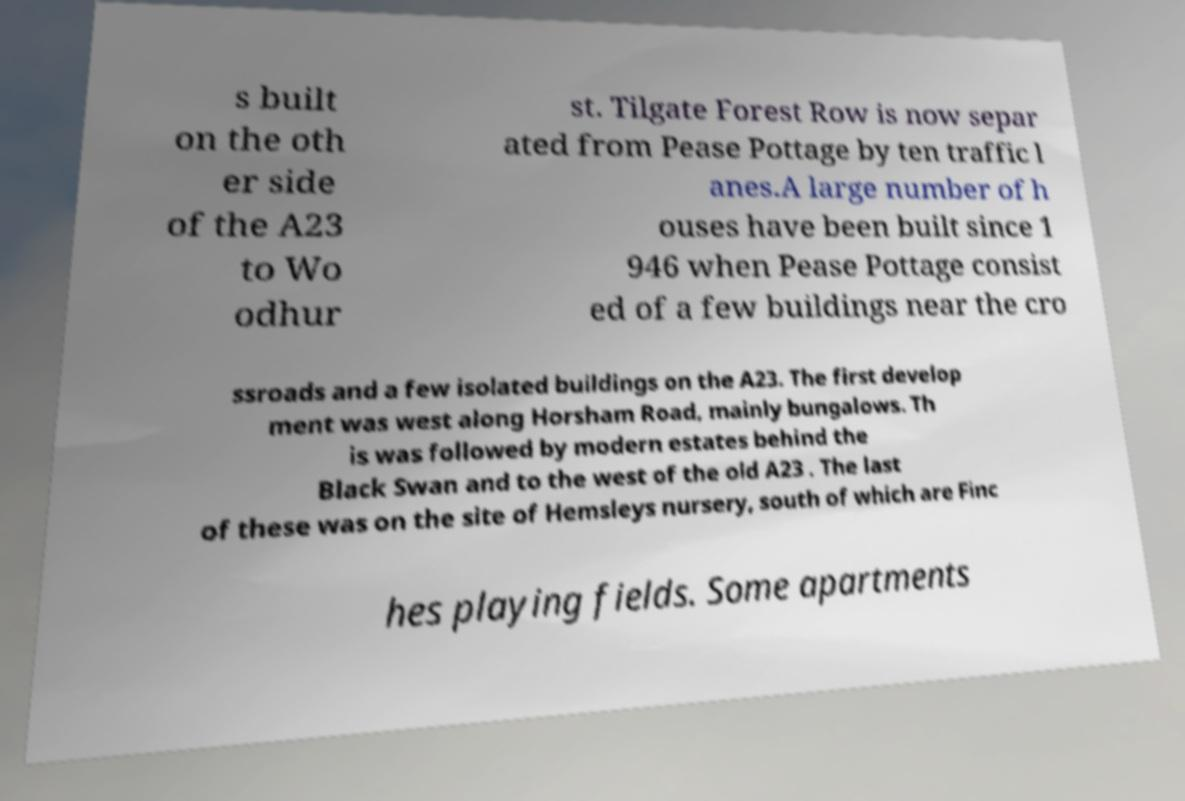Could you assist in decoding the text presented in this image and type it out clearly? s built on the oth er side of the A23 to Wo odhur st. Tilgate Forest Row is now separ ated from Pease Pottage by ten traffic l anes.A large number of h ouses have been built since 1 946 when Pease Pottage consist ed of a few buildings near the cro ssroads and a few isolated buildings on the A23. The first develop ment was west along Horsham Road, mainly bungalows. Th is was followed by modern estates behind the Black Swan and to the west of the old A23 . The last of these was on the site of Hemsleys nursery, south of which are Finc hes playing fields. Some apartments 